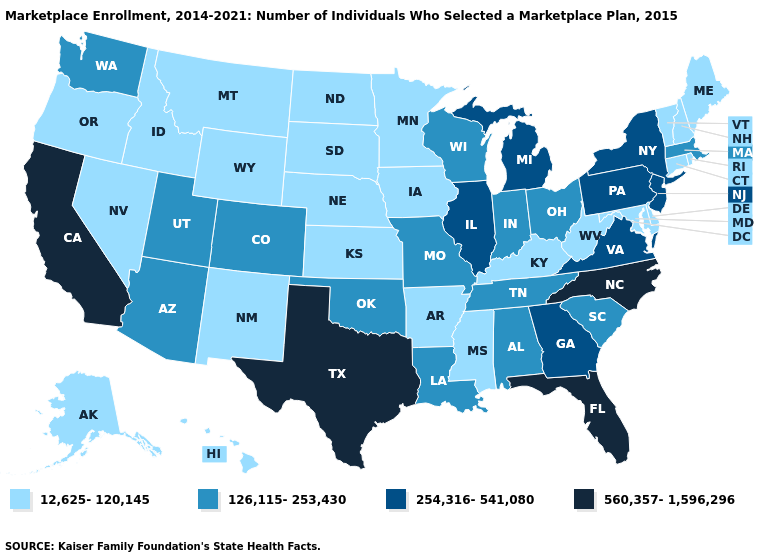Does the first symbol in the legend represent the smallest category?
Write a very short answer. Yes. Name the states that have a value in the range 12,625-120,145?
Concise answer only. Alaska, Arkansas, Connecticut, Delaware, Hawaii, Idaho, Iowa, Kansas, Kentucky, Maine, Maryland, Minnesota, Mississippi, Montana, Nebraska, Nevada, New Hampshire, New Mexico, North Dakota, Oregon, Rhode Island, South Dakota, Vermont, West Virginia, Wyoming. Name the states that have a value in the range 126,115-253,430?
Keep it brief. Alabama, Arizona, Colorado, Indiana, Louisiana, Massachusetts, Missouri, Ohio, Oklahoma, South Carolina, Tennessee, Utah, Washington, Wisconsin. What is the highest value in the Northeast ?
Write a very short answer. 254,316-541,080. What is the value of Colorado?
Give a very brief answer. 126,115-253,430. Name the states that have a value in the range 12,625-120,145?
Concise answer only. Alaska, Arkansas, Connecticut, Delaware, Hawaii, Idaho, Iowa, Kansas, Kentucky, Maine, Maryland, Minnesota, Mississippi, Montana, Nebraska, Nevada, New Hampshire, New Mexico, North Dakota, Oregon, Rhode Island, South Dakota, Vermont, West Virginia, Wyoming. What is the value of Tennessee?
Give a very brief answer. 126,115-253,430. What is the value of Arkansas?
Quick response, please. 12,625-120,145. Name the states that have a value in the range 254,316-541,080?
Write a very short answer. Georgia, Illinois, Michigan, New Jersey, New York, Pennsylvania, Virginia. Among the states that border West Virginia , does Kentucky have the lowest value?
Write a very short answer. Yes. What is the value of Maine?
Concise answer only. 12,625-120,145. Is the legend a continuous bar?
Be succinct. No. Does Washington have a higher value than Vermont?
Quick response, please. Yes. Does South Dakota have the highest value in the MidWest?
Write a very short answer. No. 